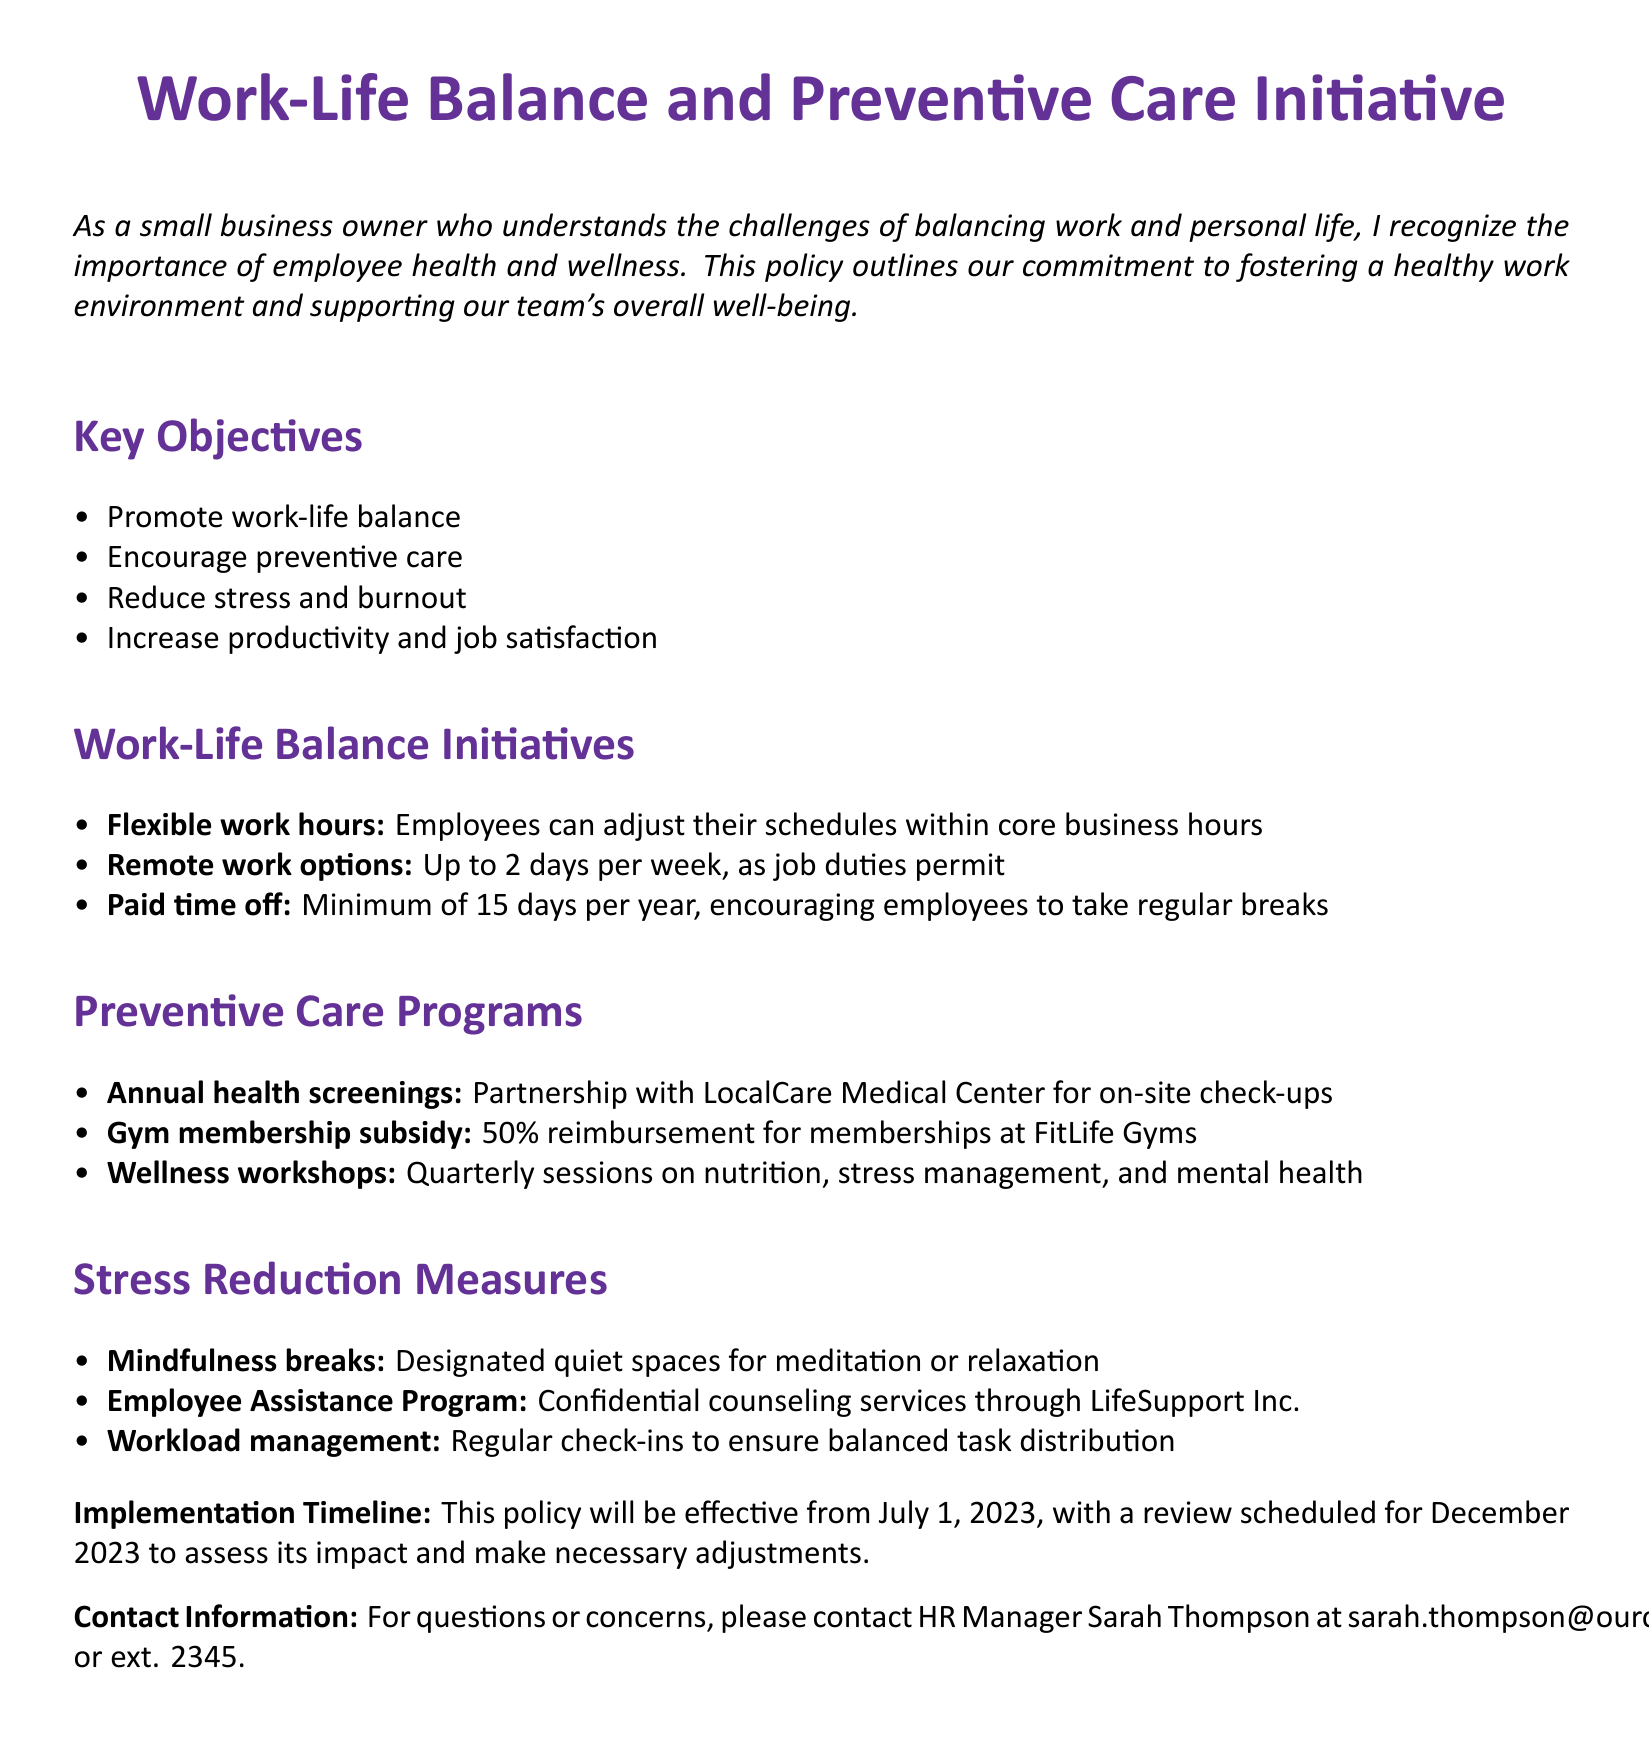What is the title of the document? The title of the document is prominently displayed at the top, highlighting the main focus of the policy.
Answer: Work-Life Balance and Preventive Care Initiative Who is the HR Manager? The HR Manager is responsible for handling questions or concerns regarding the policy, mentioned in the contact information section.
Answer: Sarah Thompson How many paid time off days are employees encouraged to take? The document specifies a minimum number of paid time off days for employees to take regular breaks.
Answer: 15 days What organization is partnered for annual health screenings? The document references a specific medical center that provides on-site check-ups as part of preventive care.
Answer: LocalCare Medical Center What percentage of gym membership reimbursement is provided? The policy document outlines the financial support given for gym memberships.
Answer: 50% What type of counseling services does the Employee Assistance Program offer? The document mentions the nature of the services available to employees through a specific program.
Answer: Confidential counseling services What is the implementation date of the policy? The document states when the policy will take effect, marking an important date in its timeline.
Answer: July 1, 2023 How often are wellness workshops held? The document indicates the frequency of wellness workshops offered to employees.
Answer: Quarterly What is one initiative aimed at reducing stress? The document lists specific measures taken to help employees manage stress.
Answer: Mindfulness breaks 